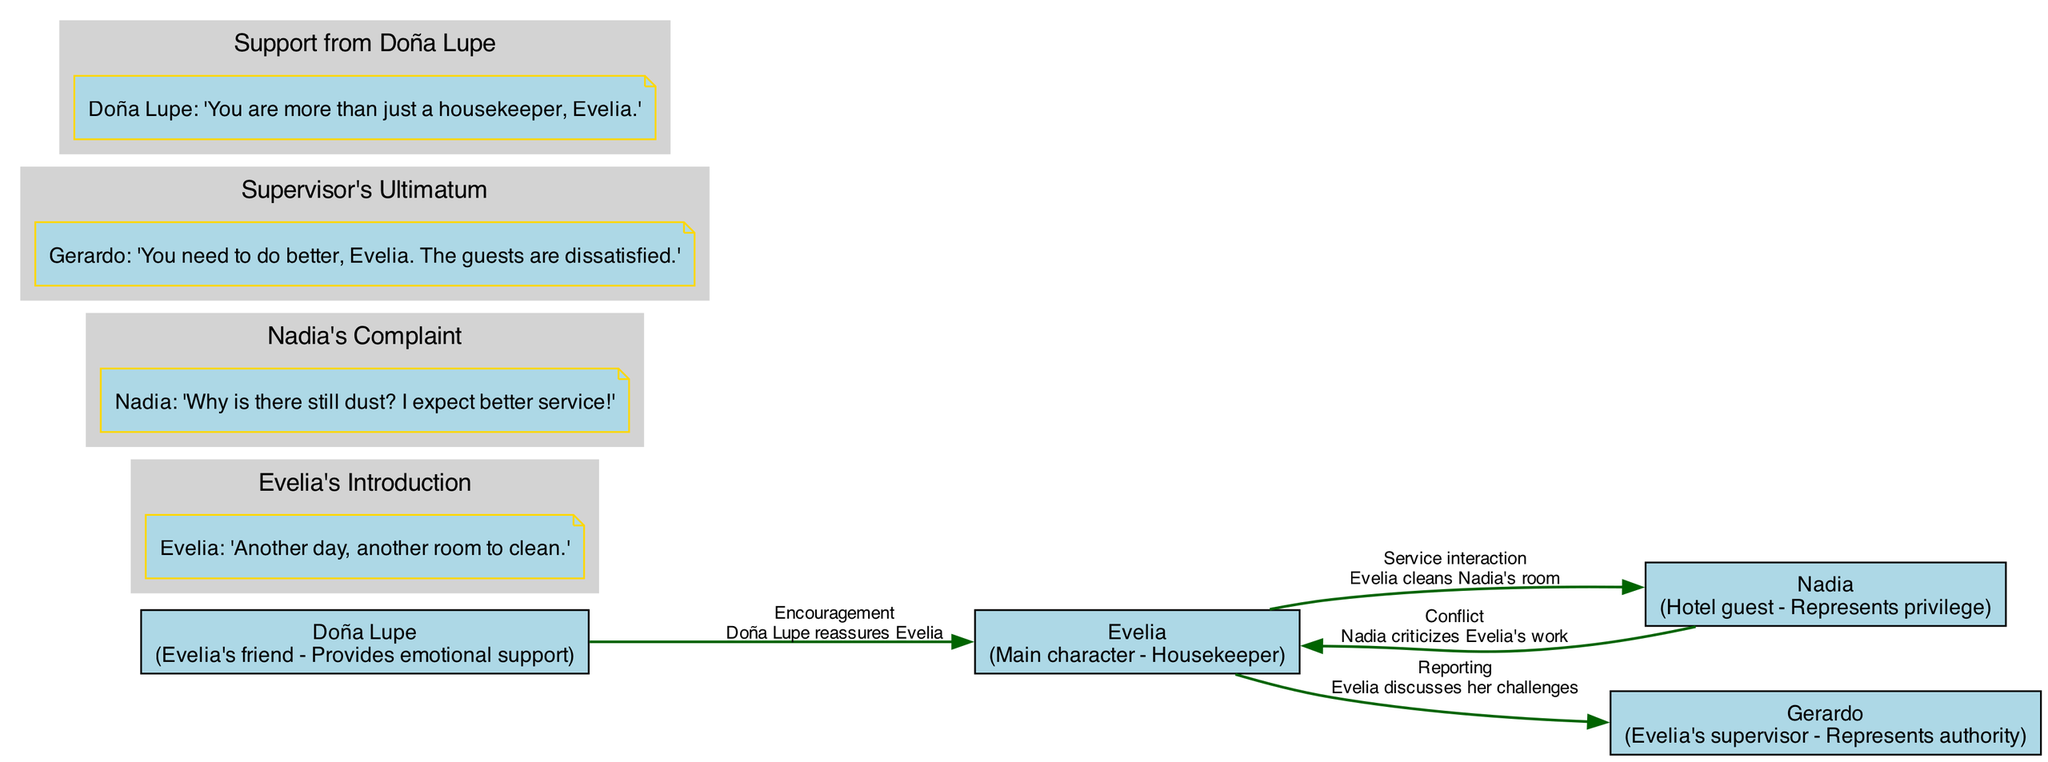What is Evelia's role in the film? The diagram indicates that Evelia is characterized as the main character and a housekeeper. This can be found by looking at the character nodes in the diagram.
Answer: Main character - Housekeeper How many key scenes are depicted in the diagram? By counting the subgraph clusters added for each key scene, we find there are four key scenes illustrated in the diagram.
Answer: 4 Who represents authority in the film? The character nodes indicate that Gerardo is identified as Evelia's supervisor, which encompasses the aspect of authority in the narrative.
Answer: Gerardo What type of interaction occurs between Nadia and Evelia? The diagram shows that Nadia criticizes Evelia's work, which is labeled as a conflict type of interaction. This is visible through the interaction edges in the diagram connecting those two characters.
Answer: Conflict What is the context of the dialogue in the scene "Support from Doña Lupe"? In the respective subgraph, the dialogue is about Doña Lupe reassuring Evelia, highlighting the emotional support Doña Lupe offers. This scene is clearly labeled in the subgraph.
Answer: Doña Lupe reassures Evelia Which character does Evelia report to? The edge connecting Evelia to Gerardo indicates that Evelia discusses her challenges with Gerardo, establishing the nature of their relationship.
Answer: Gerardo What is the first dialogue from Evelia in the diagram? The first key scene shows Evelia's introduction and includes her dialogue: 'Another day, another room to clean.' This is evident in the labeled scenes section.
Answer: 'Another day, another room to clean.' How does Doña Lupe's interaction with Evelia differ from Nadia's interaction with Evelia? The diagram indicates that Doña Lupe provides encouragement, while Nadia's interaction is based on conflict. This difference is determined by examining the types of interactions listed between the characters in the diagram.
Answer: Encouragement vs Conflict 